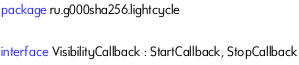<code> <loc_0><loc_0><loc_500><loc_500><_Kotlin_>package ru.g000sha256.lightcycle

interface VisibilityCallback : StartCallback, StopCallback</code> 